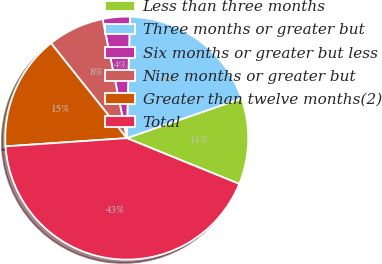Convert chart. <chart><loc_0><loc_0><loc_500><loc_500><pie_chart><fcel>Less than three months<fcel>Three months or greater but<fcel>Six months or greater but less<fcel>Nine months or greater but<fcel>Greater than twelve months(2)<fcel>Total<nl><fcel>11.45%<fcel>19.28%<fcel>3.61%<fcel>7.53%<fcel>15.36%<fcel>42.77%<nl></chart> 